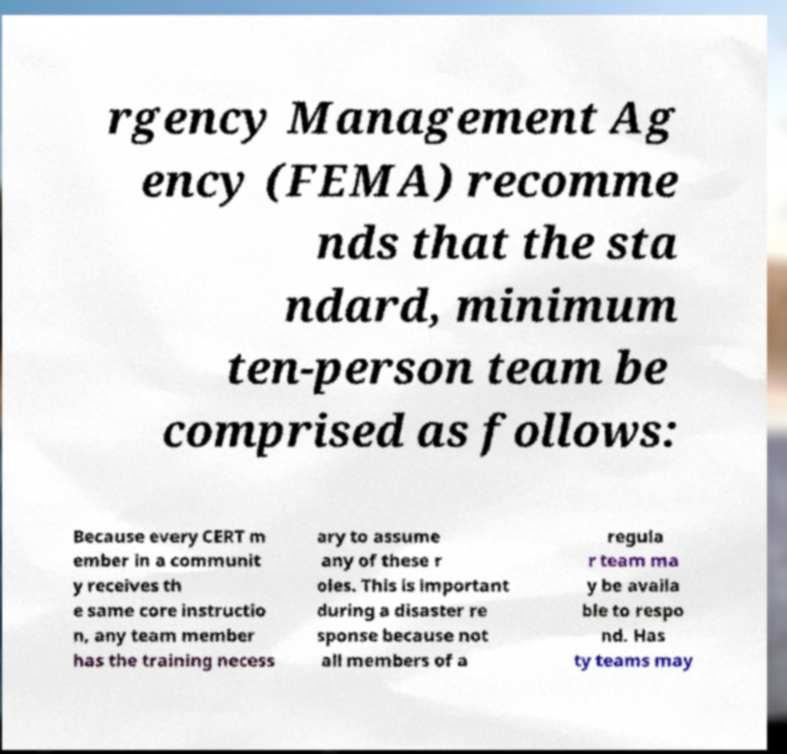Please read and relay the text visible in this image. What does it say? rgency Management Ag ency (FEMA) recomme nds that the sta ndard, minimum ten-person team be comprised as follows: Because every CERT m ember in a communit y receives th e same core instructio n, any team member has the training necess ary to assume any of these r oles. This is important during a disaster re sponse because not all members of a regula r team ma y be availa ble to respo nd. Has ty teams may 